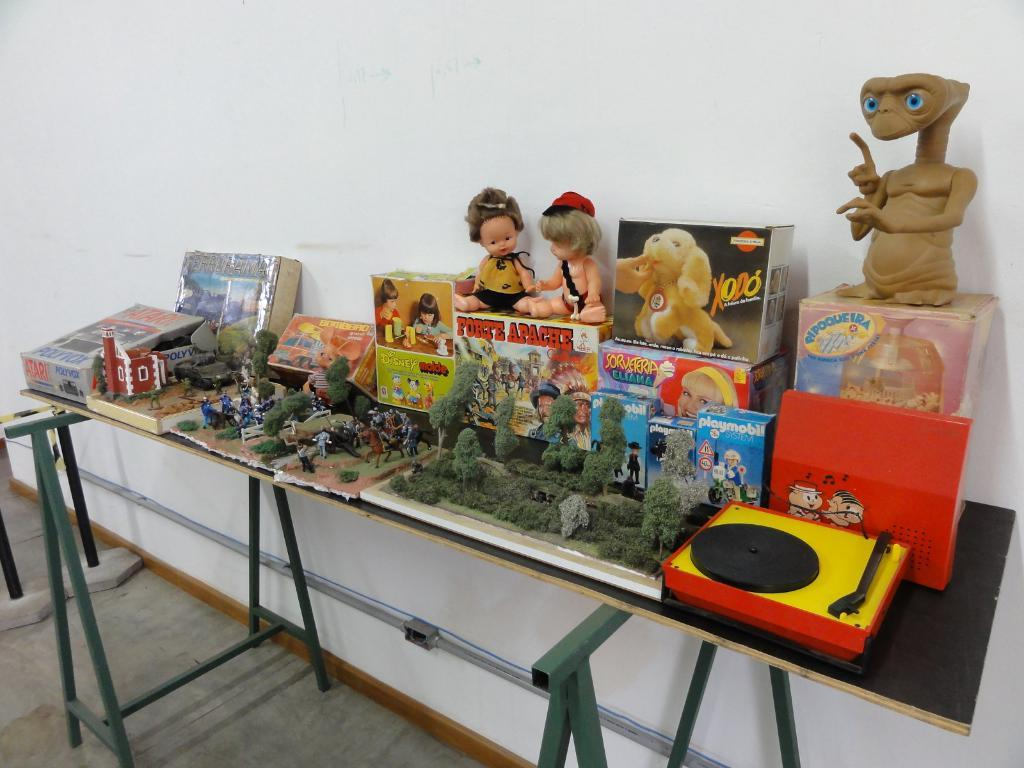<image>
Share a concise interpretation of the image provided. A table full of toys one of which is a puppy called XODO. 